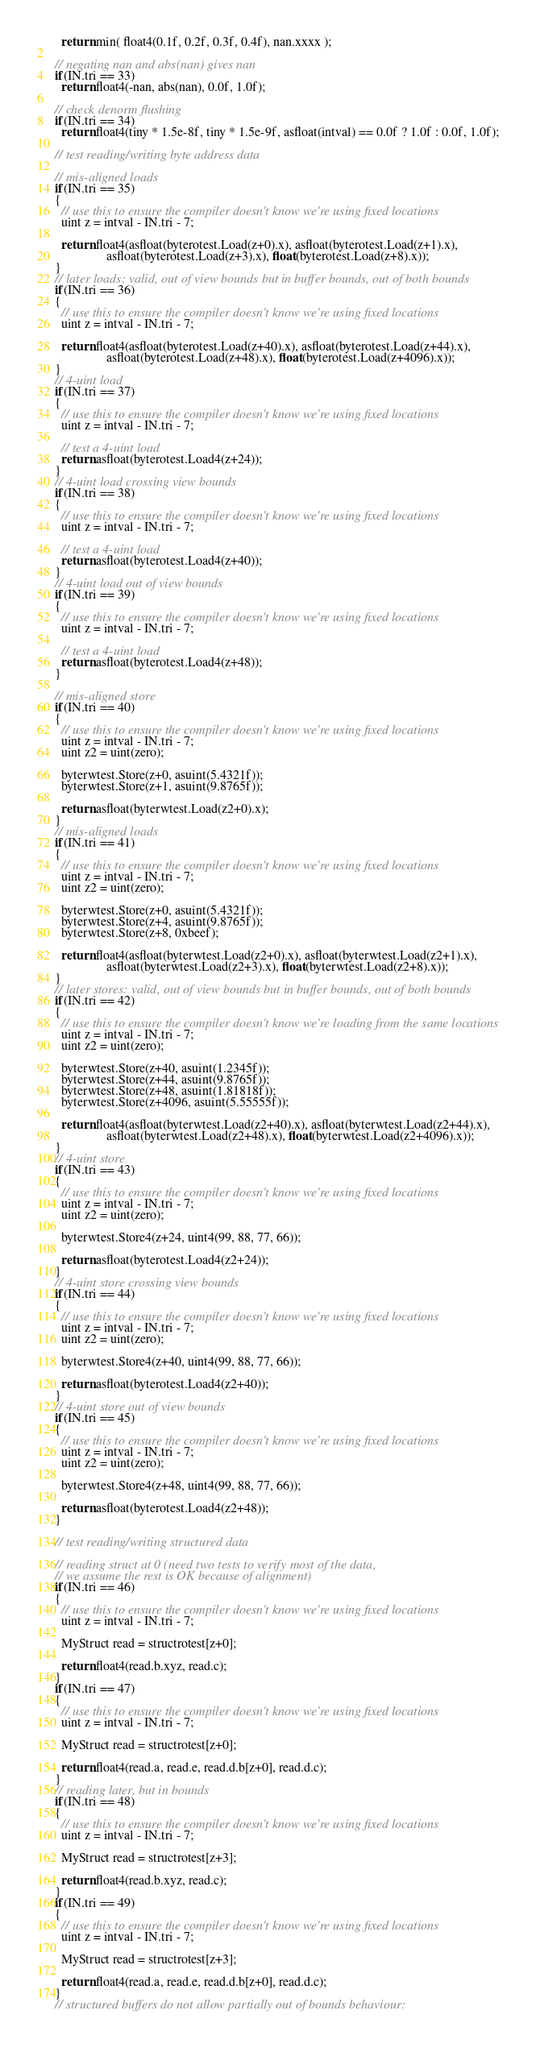<code> <loc_0><loc_0><loc_500><loc_500><_C++_>    return min( float4(0.1f, 0.2f, 0.3f, 0.4f), nan.xxxx );

  // negating nan and abs(nan) gives nan
  if(IN.tri == 33)
    return float4(-nan, abs(nan), 0.0f, 1.0f);

  // check denorm flushing
  if(IN.tri == 34)
    return float4(tiny * 1.5e-8f, tiny * 1.5e-9f, asfloat(intval) == 0.0f ? 1.0f : 0.0f, 1.0f);

  // test reading/writing byte address data

  // mis-aligned loads
  if(IN.tri == 35)
  {
    // use this to ensure the compiler doesn't know we're using fixed locations
    uint z = intval - IN.tri - 7;

    return float4(asfloat(byterotest.Load(z+0).x), asfloat(byterotest.Load(z+1).x),
                  asfloat(byterotest.Load(z+3).x), float(byterotest.Load(z+8).x));
  }
  // later loads: valid, out of view bounds but in buffer bounds, out of both bounds
  if(IN.tri == 36)
  {
    // use this to ensure the compiler doesn't know we're using fixed locations
    uint z = intval - IN.tri - 7;

    return float4(asfloat(byterotest.Load(z+40).x), asfloat(byterotest.Load(z+44).x),
                  asfloat(byterotest.Load(z+48).x), float(byterotest.Load(z+4096).x));
  }
  // 4-uint load
  if(IN.tri == 37)
  {
    // use this to ensure the compiler doesn't know we're using fixed locations
    uint z = intval - IN.tri - 7;

    // test a 4-uint load
    return asfloat(byterotest.Load4(z+24));
  }
  // 4-uint load crossing view bounds
  if(IN.tri == 38)
  {
    // use this to ensure the compiler doesn't know we're using fixed locations
    uint z = intval - IN.tri - 7;

    // test a 4-uint load
    return asfloat(byterotest.Load4(z+40));
  }
  // 4-uint load out of view bounds
  if(IN.tri == 39)
  {
    // use this to ensure the compiler doesn't know we're using fixed locations
    uint z = intval - IN.tri - 7;

    // test a 4-uint load
    return asfloat(byterotest.Load4(z+48));
  }

  // mis-aligned store
  if(IN.tri == 40)
  {
    // use this to ensure the compiler doesn't know we're using fixed locations
    uint z = intval - IN.tri - 7;
    uint z2 = uint(zero);

    byterwtest.Store(z+0, asuint(5.4321f));
    byterwtest.Store(z+1, asuint(9.8765f));

    return asfloat(byterwtest.Load(z2+0).x);
  }
  // mis-aligned loads
  if(IN.tri == 41)
  {
    // use this to ensure the compiler doesn't know we're using fixed locations
    uint z = intval - IN.tri - 7;
    uint z2 = uint(zero);

    byterwtest.Store(z+0, asuint(5.4321f));
    byterwtest.Store(z+4, asuint(9.8765f));
    byterwtest.Store(z+8, 0xbeef);

    return float4(asfloat(byterwtest.Load(z2+0).x), asfloat(byterwtest.Load(z2+1).x),
                  asfloat(byterwtest.Load(z2+3).x), float(byterwtest.Load(z2+8).x));
  }
  // later stores: valid, out of view bounds but in buffer bounds, out of both bounds
  if(IN.tri == 42)
  {
    // use this to ensure the compiler doesn't know we're loading from the same locations
    uint z = intval - IN.tri - 7;
    uint z2 = uint(zero);

    byterwtest.Store(z+40, asuint(1.2345f));
    byterwtest.Store(z+44, asuint(9.8765f));
    byterwtest.Store(z+48, asuint(1.81818f));
    byterwtest.Store(z+4096, asuint(5.55555f));

    return float4(asfloat(byterwtest.Load(z2+40).x), asfloat(byterwtest.Load(z2+44).x),
                  asfloat(byterwtest.Load(z2+48).x), float(byterwtest.Load(z2+4096).x));
  }
  // 4-uint store
  if(IN.tri == 43)
  {
    // use this to ensure the compiler doesn't know we're using fixed locations
    uint z = intval - IN.tri - 7;
    uint z2 = uint(zero);

    byterwtest.Store4(z+24, uint4(99, 88, 77, 66));

    return asfloat(byterotest.Load4(z2+24));
  }
  // 4-uint store crossing view bounds
  if(IN.tri == 44)
  {
    // use this to ensure the compiler doesn't know we're using fixed locations
    uint z = intval - IN.tri - 7;
    uint z2 = uint(zero);

    byterwtest.Store4(z+40, uint4(99, 88, 77, 66));

    return asfloat(byterotest.Load4(z2+40));
  }
  // 4-uint store out of view bounds
  if(IN.tri == 45)
  {
    // use this to ensure the compiler doesn't know we're using fixed locations
    uint z = intval - IN.tri - 7;
    uint z2 = uint(zero);

    byterwtest.Store4(z+48, uint4(99, 88, 77, 66));

    return asfloat(byterotest.Load4(z2+48));
  }

  // test reading/writing structured data

  // reading struct at 0 (need two tests to verify most of the data,
  // we assume the rest is OK because of alignment)
  if(IN.tri == 46)
  {
    // use this to ensure the compiler doesn't know we're using fixed locations
    uint z = intval - IN.tri - 7;

    MyStruct read = structrotest[z+0];

    return float4(read.b.xyz, read.c);
  }
  if(IN.tri == 47)
  {
    // use this to ensure the compiler doesn't know we're using fixed locations
    uint z = intval - IN.tri - 7;

    MyStruct read = structrotest[z+0];

    return float4(read.a, read.e, read.d.b[z+0], read.d.c);
  }
  // reading later, but in bounds
  if(IN.tri == 48)
  {
    // use this to ensure the compiler doesn't know we're using fixed locations
    uint z = intval - IN.tri - 7;

    MyStruct read = structrotest[z+3];

    return float4(read.b.xyz, read.c);
  }
  if(IN.tri == 49)
  {
    // use this to ensure the compiler doesn't know we're using fixed locations
    uint z = intval - IN.tri - 7;

    MyStruct read = structrotest[z+3];

    return float4(read.a, read.e, read.d.b[z+0], read.d.c);
  }
  // structured buffers do not allow partially out of bounds behaviour:</code> 